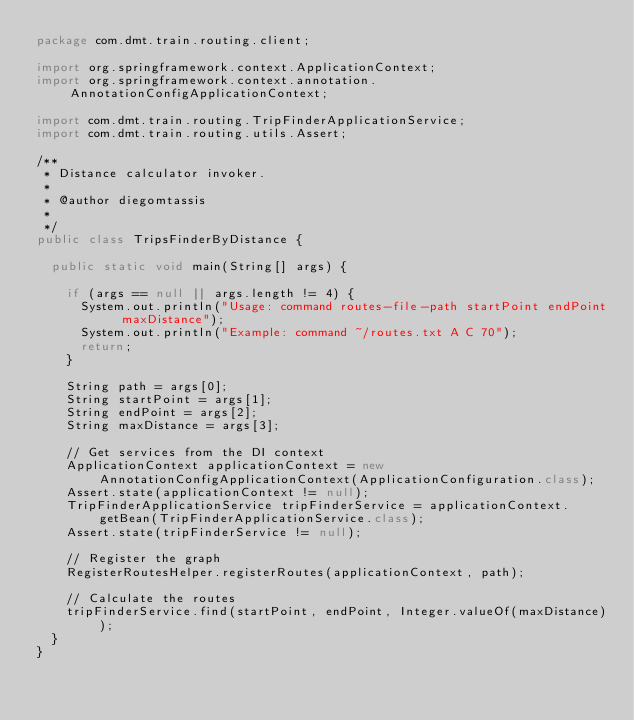<code> <loc_0><loc_0><loc_500><loc_500><_Java_>package com.dmt.train.routing.client;

import org.springframework.context.ApplicationContext;
import org.springframework.context.annotation.AnnotationConfigApplicationContext;

import com.dmt.train.routing.TripFinderApplicationService;
import com.dmt.train.routing.utils.Assert;

/**
 * Distance calculator invoker.
 * 
 * @author diegomtassis
 *
 */
public class TripsFinderByDistance {

	public static void main(String[] args) {

		if (args == null || args.length != 4) {
			System.out.println("Usage: command routes-file-path startPoint endPoint maxDistance");
			System.out.println("Example: command ~/routes.txt A C 70");
			return;
		}

		String path = args[0];
		String startPoint = args[1];
		String endPoint = args[2];
		String maxDistance = args[3];

		// Get services from the DI context
		ApplicationContext applicationContext = new AnnotationConfigApplicationContext(ApplicationConfiguration.class);
		Assert.state(applicationContext != null);
		TripFinderApplicationService tripFinderService = applicationContext.getBean(TripFinderApplicationService.class);
		Assert.state(tripFinderService != null);

		// Register the graph
		RegisterRoutesHelper.registerRoutes(applicationContext, path);

		// Calculate the routes
		tripFinderService.find(startPoint, endPoint, Integer.valueOf(maxDistance));
	}
}
</code> 